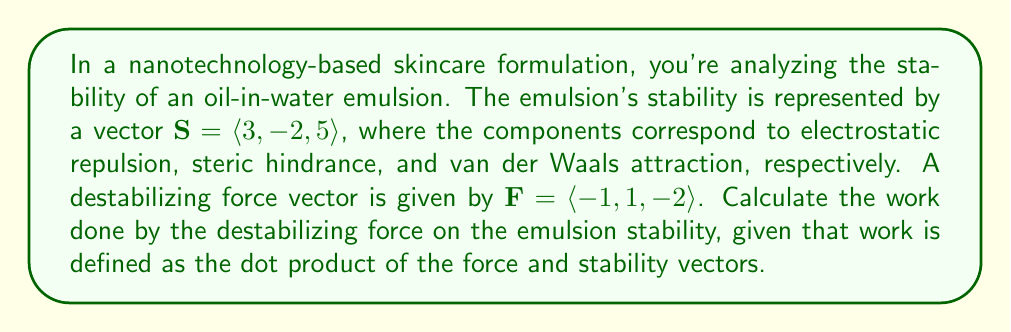Help me with this question. To solve this problem, we need to calculate the dot product of the stability vector $\mathbf{S}$ and the force vector $\mathbf{F}$. The dot product represents the work done by the force on the emulsion stability.

The dot product of two vectors $\mathbf{a} = \langle a_1, a_2, a_3 \rangle$ and $\mathbf{b} = \langle b_1, b_2, b_3 \rangle$ is defined as:

$$\mathbf{a} \cdot \mathbf{b} = a_1b_1 + a_2b_2 + a_3b_3$$

For our problem:
$\mathbf{S} = \langle 3, -2, 5 \rangle$
$\mathbf{F} = \langle -1, 1, -2 \rangle$

Calculating the dot product:

$$\begin{align}
\mathbf{S} \cdot \mathbf{F} &= (3)(-1) + (-2)(1) + (5)(-2) \\
&= -3 - 2 - 10 \\
&= -15
\end{align}$$

The negative result indicates that the force is working against the stability of the emulsion, which is consistent with it being a destabilizing force.
Answer: The work done by the destabilizing force on the emulsion stability is $-15$ (in appropriate units of work). 